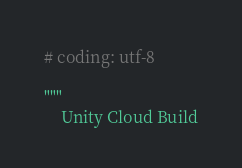<code> <loc_0><loc_0><loc_500><loc_500><_Python_># coding: utf-8

"""
    Unity Cloud Build
</code> 